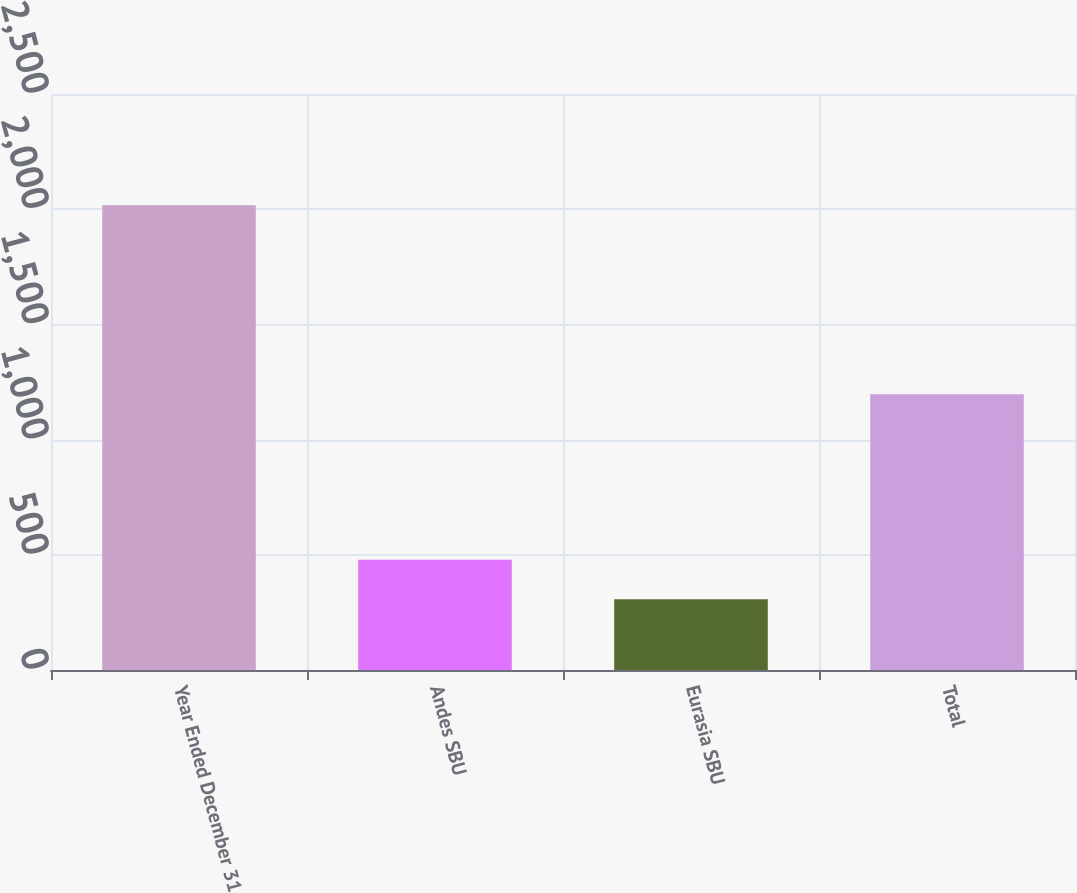Convert chart to OTSL. <chart><loc_0><loc_0><loc_500><loc_500><bar_chart><fcel>Year Ended December 31<fcel>Andes SBU<fcel>Eurasia SBU<fcel>Total<nl><fcel>2017<fcel>478<fcel>307<fcel>1197<nl></chart> 